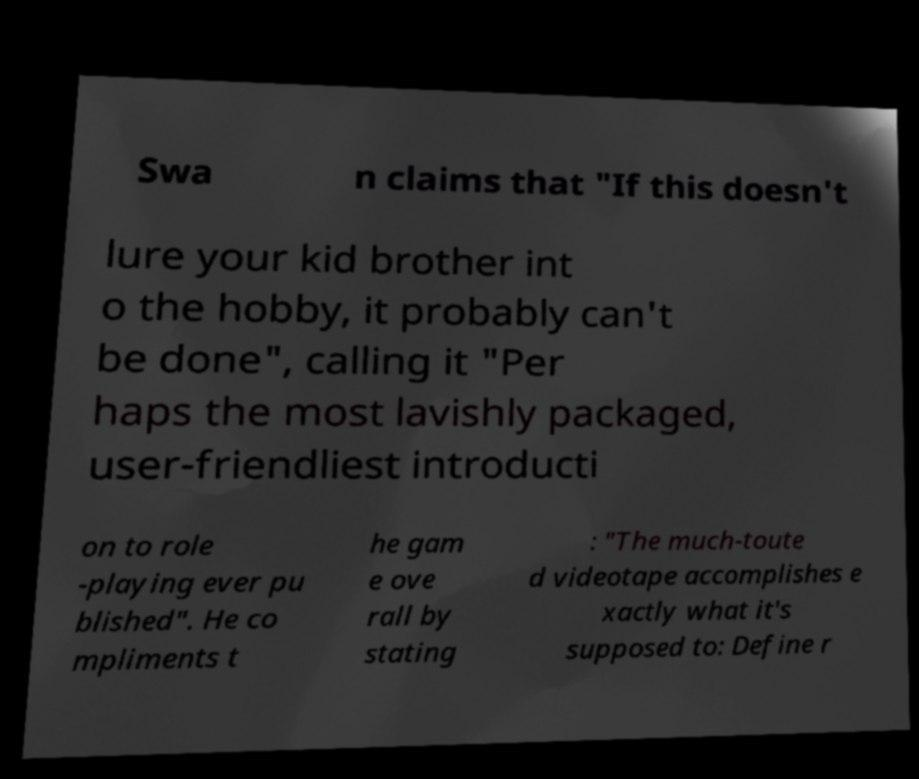Can you accurately transcribe the text from the provided image for me? Swa n claims that "If this doesn't lure your kid brother int o the hobby, it probably can't be done", calling it "Per haps the most lavishly packaged, user-friendliest introducti on to role -playing ever pu blished". He co mpliments t he gam e ove rall by stating : "The much-toute d videotape accomplishes e xactly what it's supposed to: Define r 